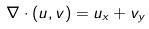Convert formula to latex. <formula><loc_0><loc_0><loc_500><loc_500>\nabla \cdot ( u , v ) = u _ { x } + v _ { y }</formula> 